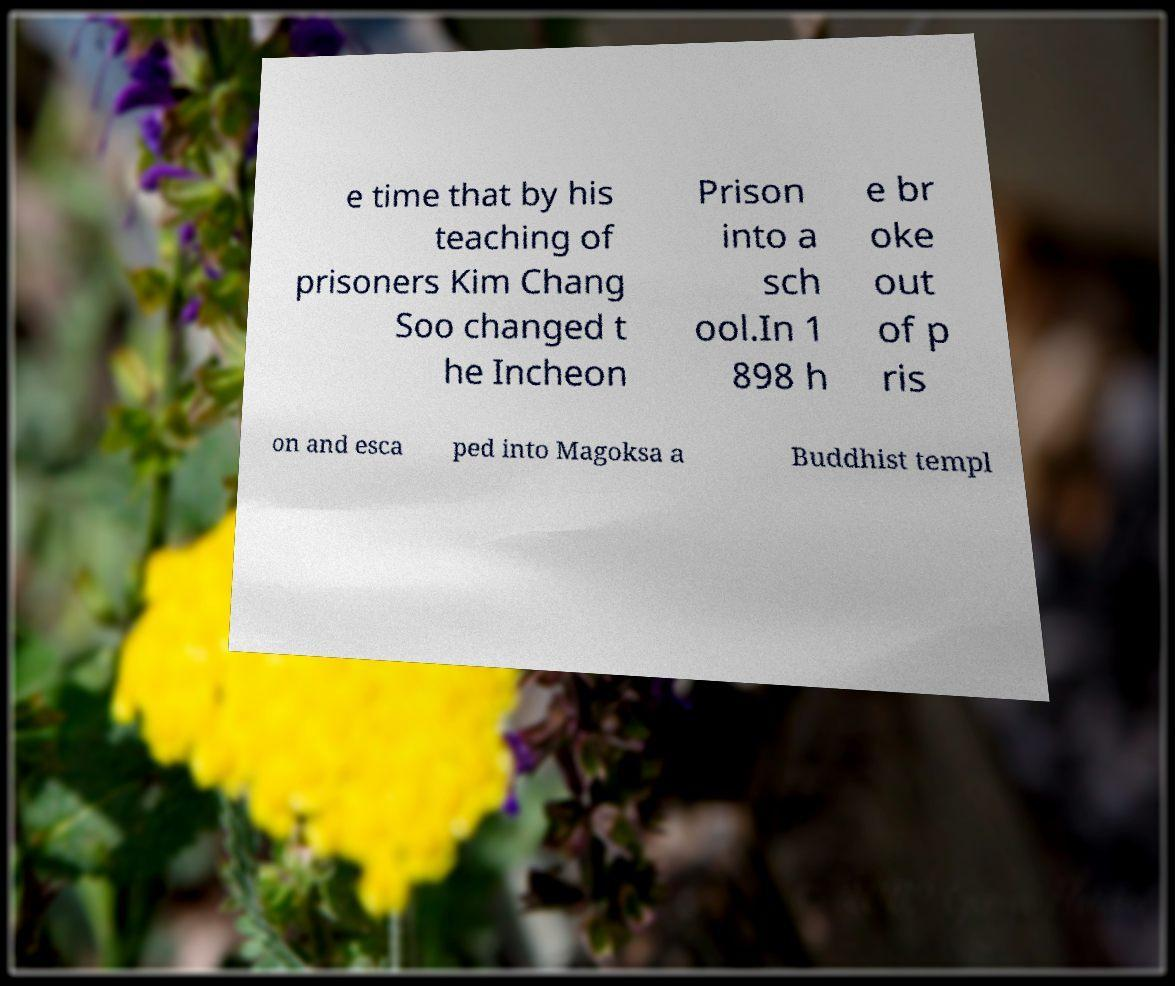Please read and relay the text visible in this image. What does it say? e time that by his teaching of prisoners Kim Chang Soo changed t he Incheon Prison into a sch ool.In 1 898 h e br oke out of p ris on and esca ped into Magoksa a Buddhist templ 